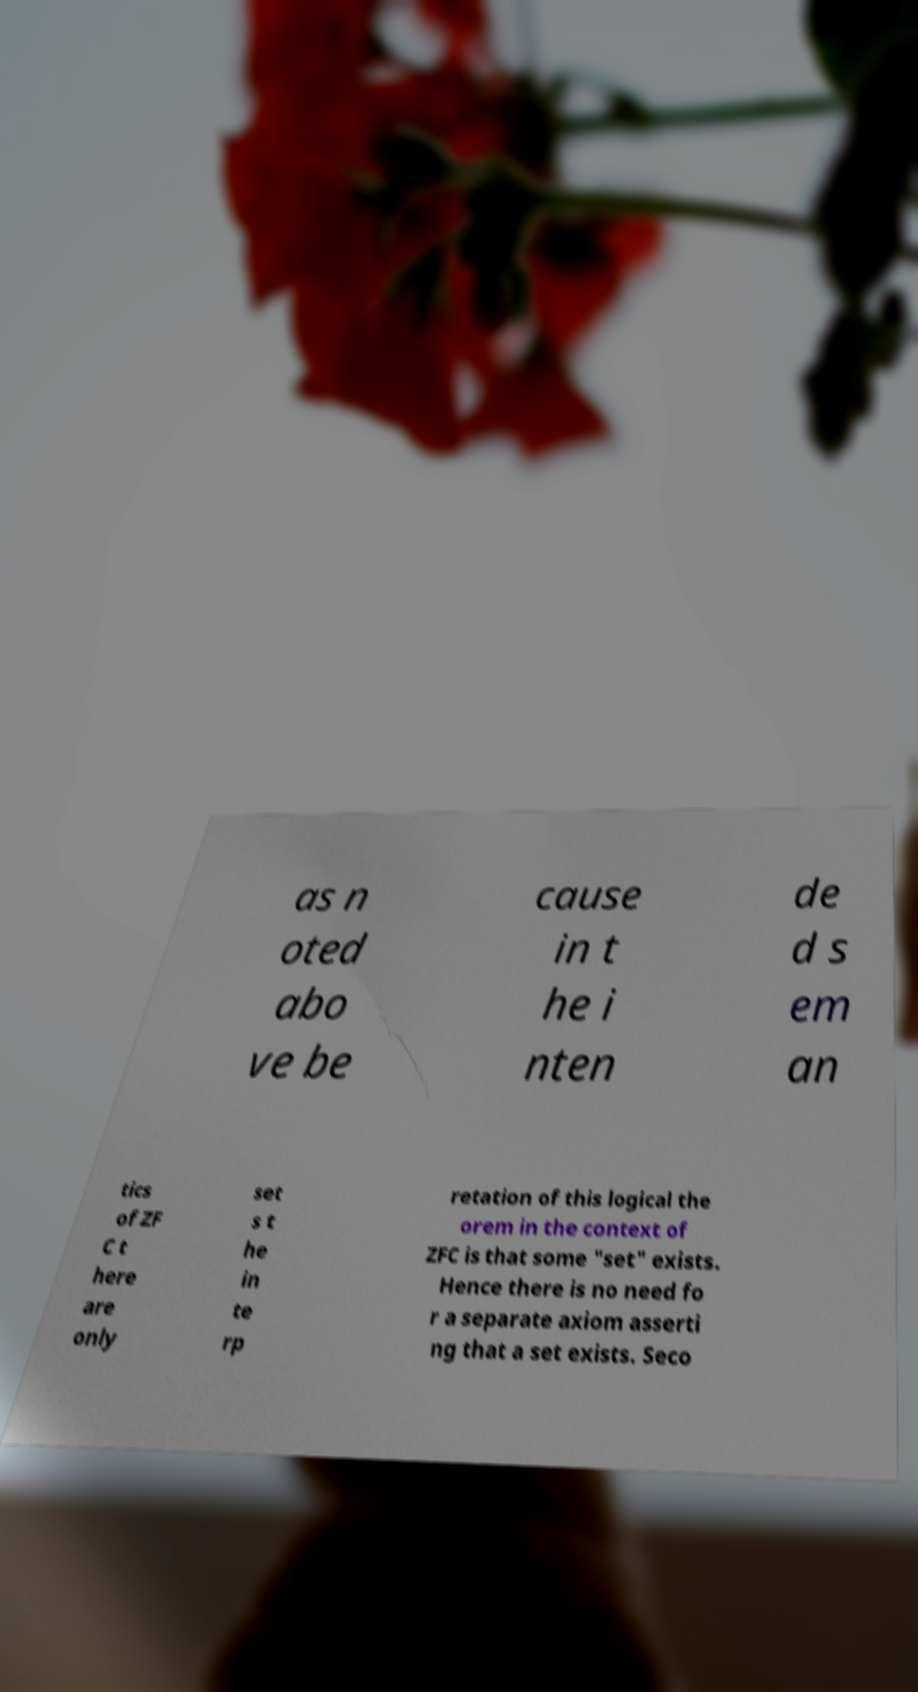I need the written content from this picture converted into text. Can you do that? as n oted abo ve be cause in t he i nten de d s em an tics of ZF C t here are only set s t he in te rp retation of this logical the orem in the context of ZFC is that some "set" exists. Hence there is no need fo r a separate axiom asserti ng that a set exists. Seco 